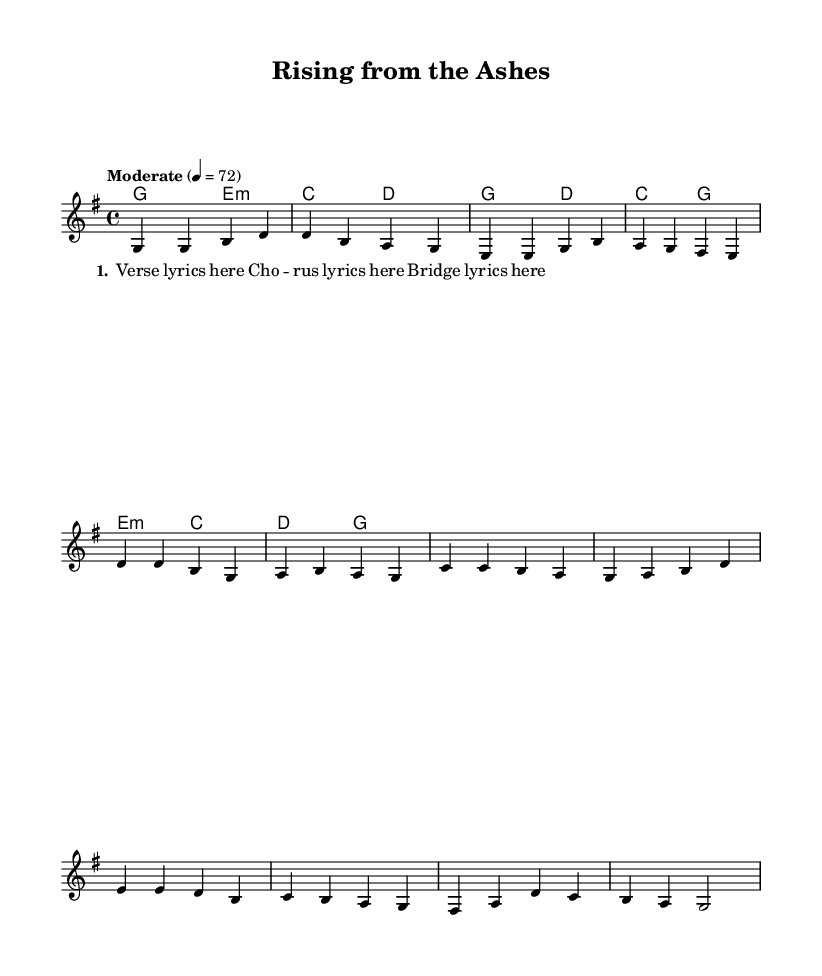What is the key signature of this music? The key signature indicated is G major, which has one sharp (F#). This is evident in the global section of the LilyPond code (indicated by `\key g \major`).
Answer: G major What is the time signature of this piece? The time signature is 4/4, which means there are four beats in each measure. This is stated in the global section of the sheet music with `\time 4/4`.
Answer: 4/4 What is the tempo marking for this music? The tempo marking is "Moderate" and is indicated by the notation `\tempo "Moderate" 4 = 72`, meaning that there are 72 beats per minute.
Answer: Moderate What is the structure of the song? The song structure consists of a verse, chorus, and bridge, as indicated in the melody and harmony sections of the code. It follows the pattern of Verse - Chorus - Bridge.
Answer: Verse - Chorus - Bridge Which chords are used in the verse? The chords for the verse are G major and E minor, followed by C major and D major. This is confirmed by looking at the `\harmonies` section listed under the verse sequence.
Answer: G E minor C D What theme is explored in the lyrics? The theme explored in the lyrics revolves around personal growth and second chances, which is a common focus in uplifting country ballads. This can be inferred from the title "Rising from the Ashes."
Answer: Personal growth and second chances 